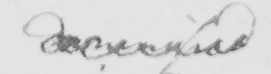What text is written in this handwritten line? deceived 